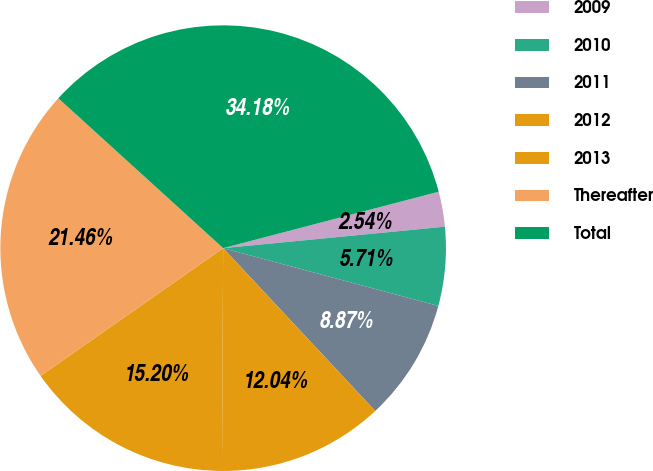<chart> <loc_0><loc_0><loc_500><loc_500><pie_chart><fcel>2009<fcel>2010<fcel>2011<fcel>2012<fcel>2013<fcel>Thereafter<fcel>Total<nl><fcel>2.54%<fcel>5.71%<fcel>8.87%<fcel>12.04%<fcel>15.2%<fcel>21.46%<fcel>34.18%<nl></chart> 